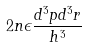Convert formula to latex. <formula><loc_0><loc_0><loc_500><loc_500>2 n \epsilon \frac { d ^ { 3 } p d ^ { 3 } r } { h ^ { 3 } }</formula> 